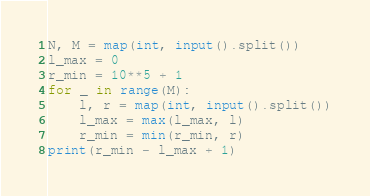<code> <loc_0><loc_0><loc_500><loc_500><_Python_>N, M = map(int, input().split())
l_max = 0
r_min = 10**5 + 1
for _ in range(M):
    l, r = map(int, input().split())
    l_max = max(l_max, l)
    r_min = min(r_min, r)
print(r_min - l_max + 1)
</code> 